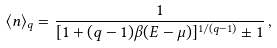<formula> <loc_0><loc_0><loc_500><loc_500>\langle n \rangle _ { q } = \frac { 1 } { [ 1 + ( q - 1 ) \beta ( E - \mu ) ] ^ { 1 / ( q - 1 ) } \pm 1 } \, ,</formula> 